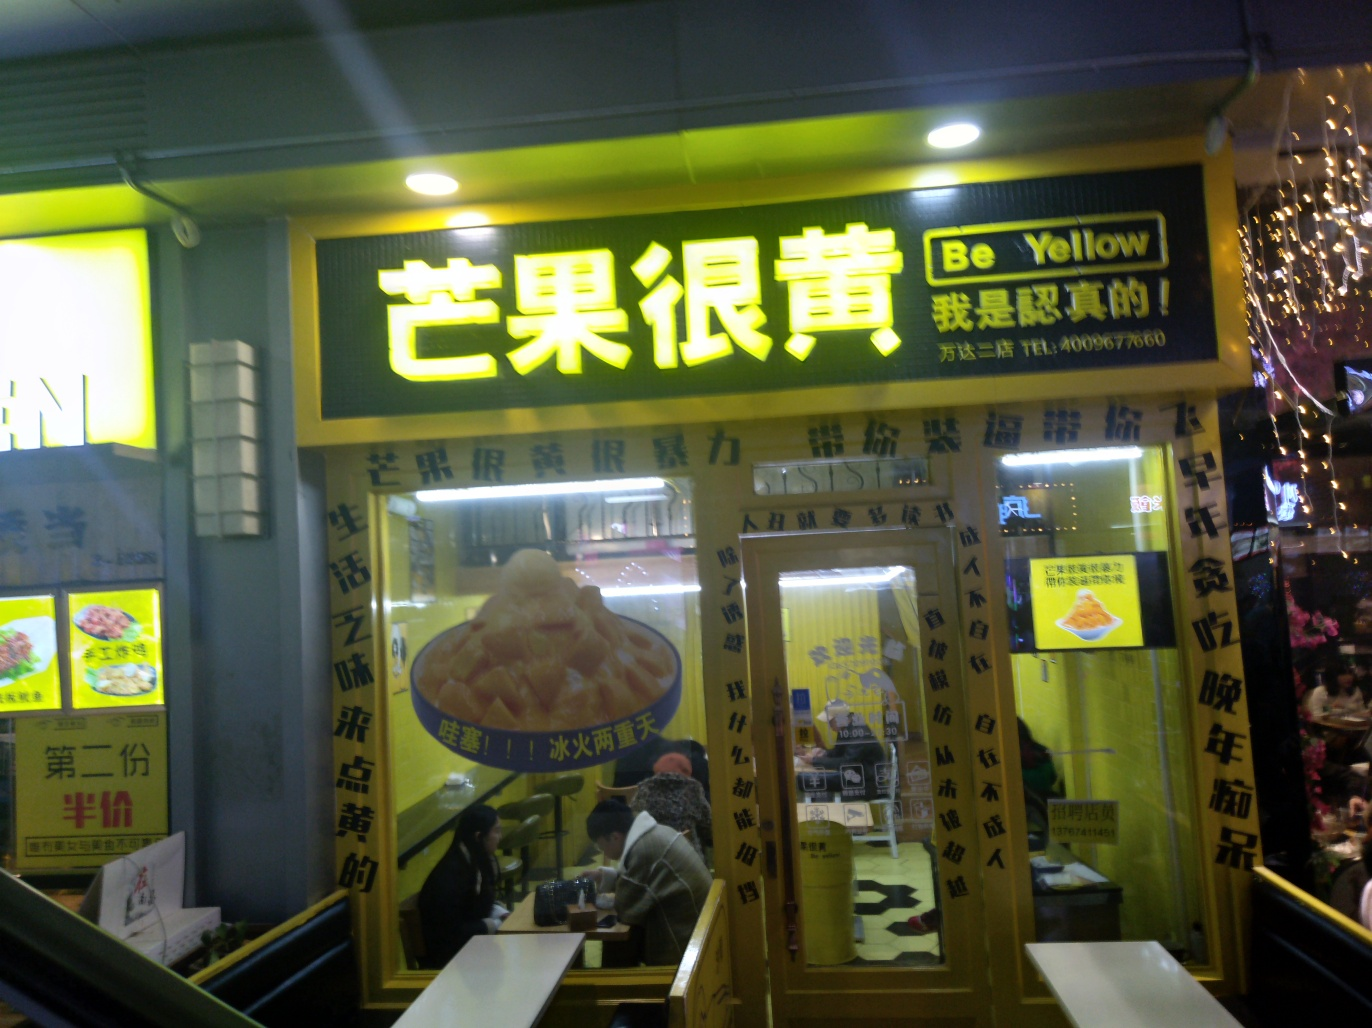What kind of food does this restaurant specialize in? The restaurant featured in the image appears to specialize in Chinese cuisine, indicated by the characters on the sign and the food pictured in the posters outside the establishment. One can observe promotional images of dishes that suggest a focus on hearty, perhaps regional, offerings. 